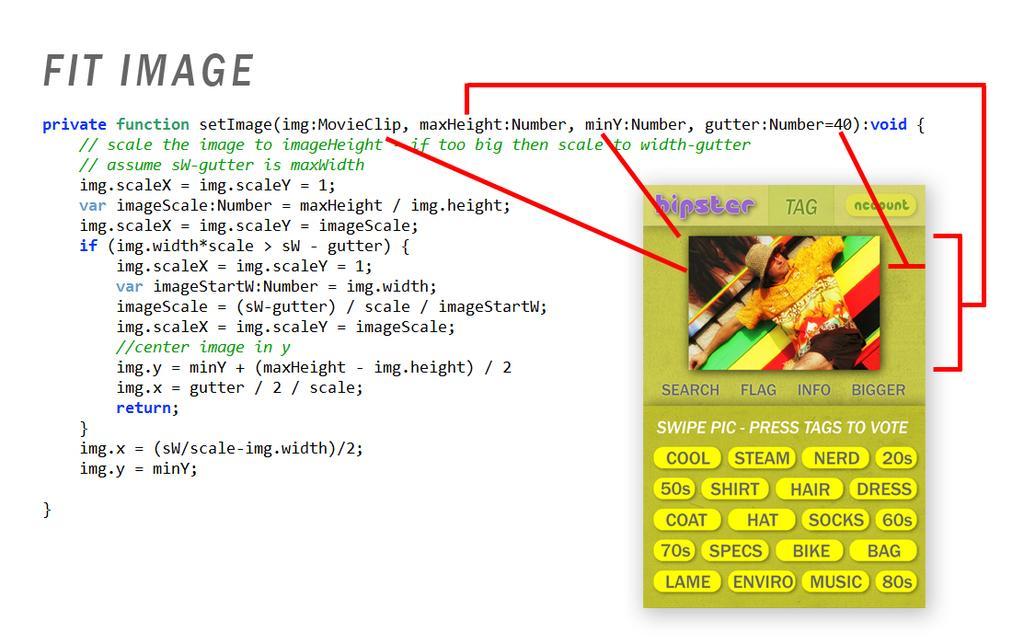In one or two sentences, can you explain what this image depicts? In this picture I can see the program coding on the left side which is representing the image. I can see a person wearing a hat and sitting on the bench and stretching his hands on the bench. I can see some key button on the image. I can see the red lines representing the image. 